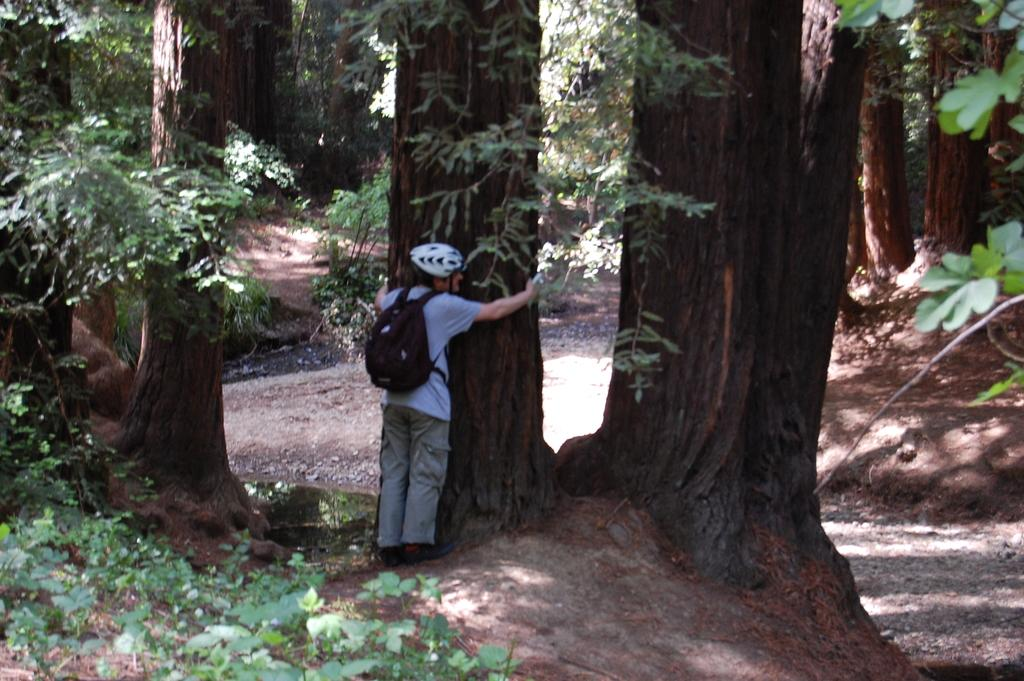What is the person in the image doing? The person is standing in the image and holding a tree trunk. What is the person wearing that might be used for protection? The person is wearing a helmet for protection. What else is the person carrying in the image? The person is wearing a bag. What type of vegetation can be seen in the image? There are plants and trees in the image. What can be seen in the background of the image? The way (possibly a path or road) is visible in the image. How does the person collect rainwater in the image? There is no mention of rainwater or a bucket in the image, so it is not possible to answer that question. 